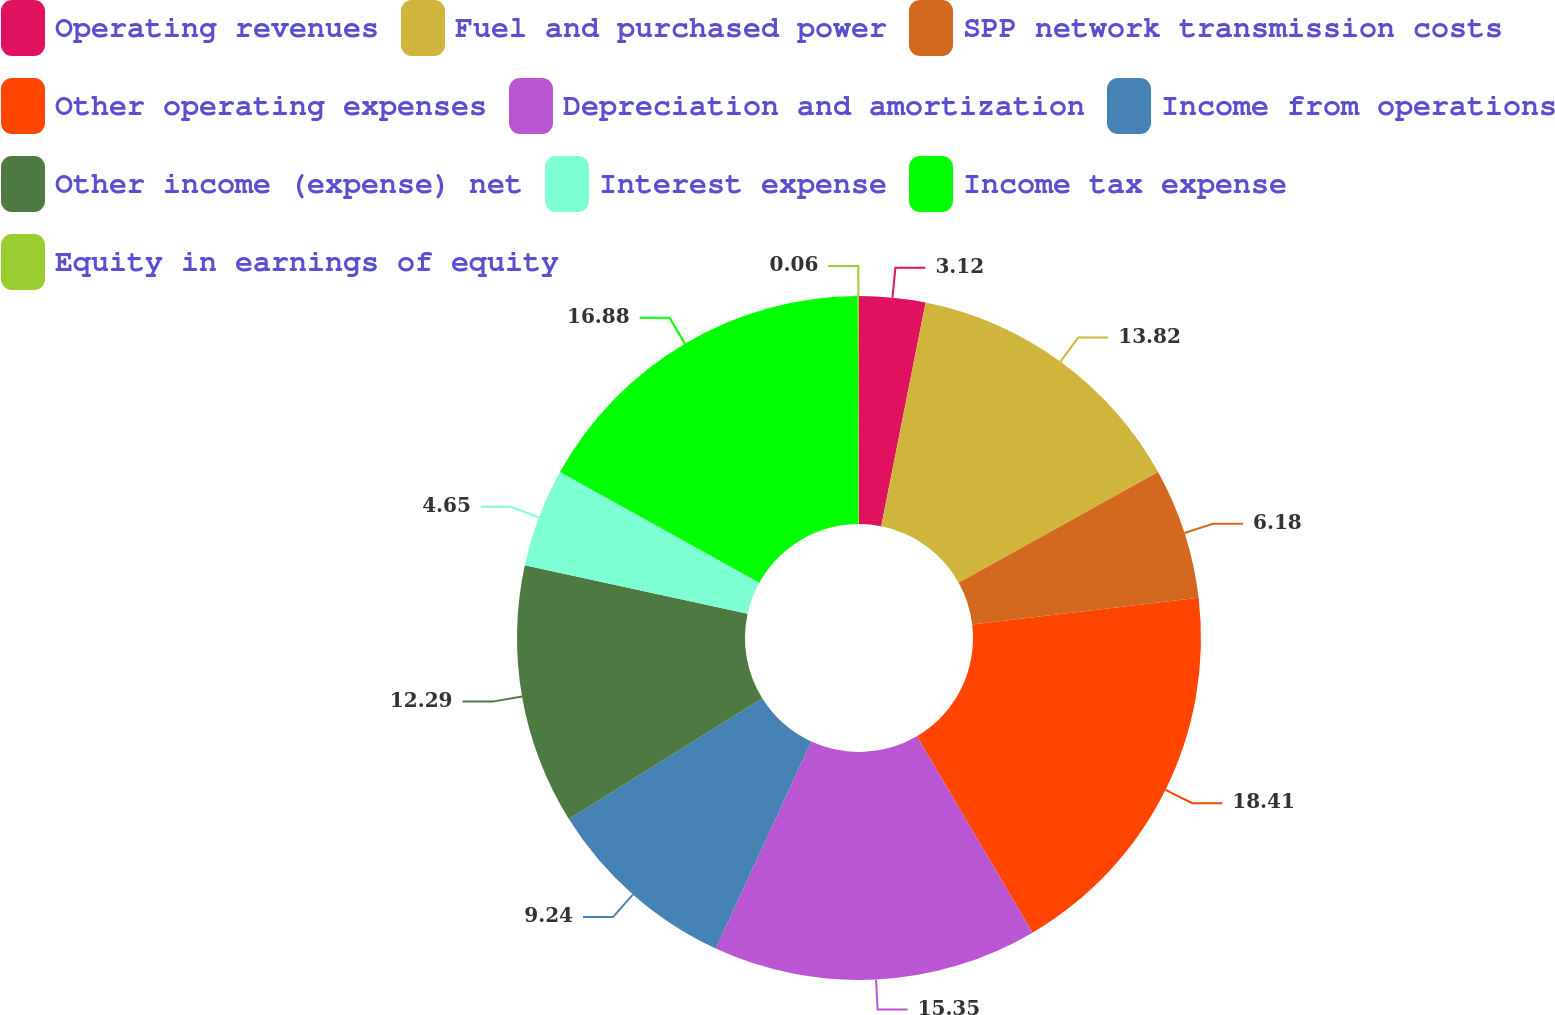<chart> <loc_0><loc_0><loc_500><loc_500><pie_chart><fcel>Operating revenues<fcel>Fuel and purchased power<fcel>SPP network transmission costs<fcel>Other operating expenses<fcel>Depreciation and amortization<fcel>Income from operations<fcel>Other income (expense) net<fcel>Interest expense<fcel>Income tax expense<fcel>Equity in earnings of equity<nl><fcel>3.12%<fcel>13.82%<fcel>6.18%<fcel>18.41%<fcel>15.35%<fcel>9.24%<fcel>12.29%<fcel>4.65%<fcel>16.88%<fcel>0.06%<nl></chart> 